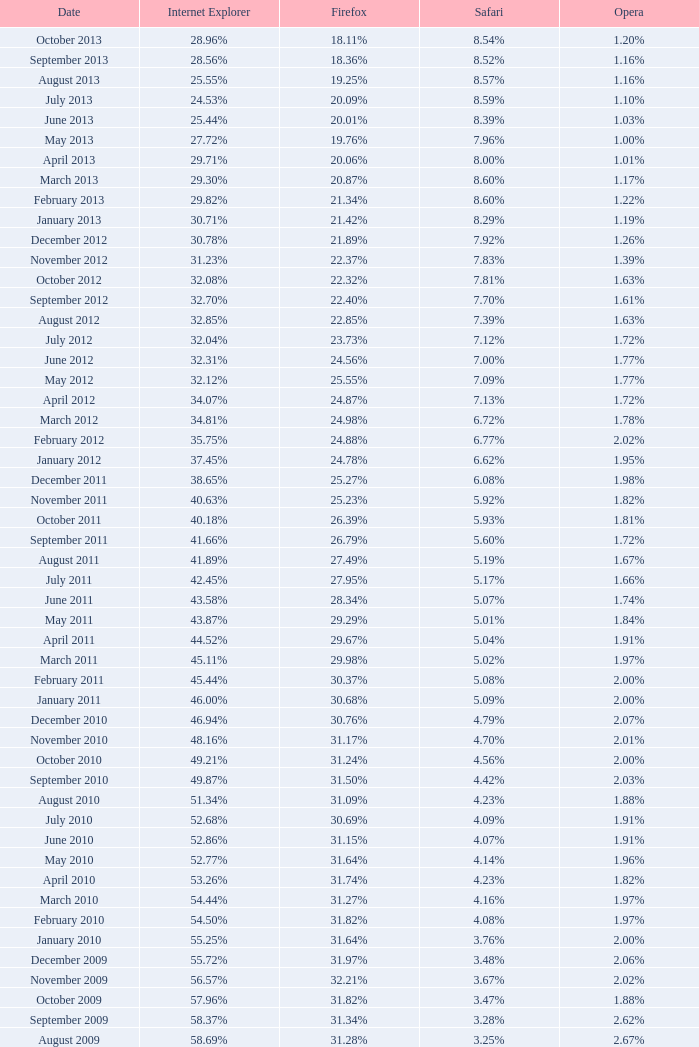What percentage of browsers were using Internet Explorer in April 2009? 61.88%. 